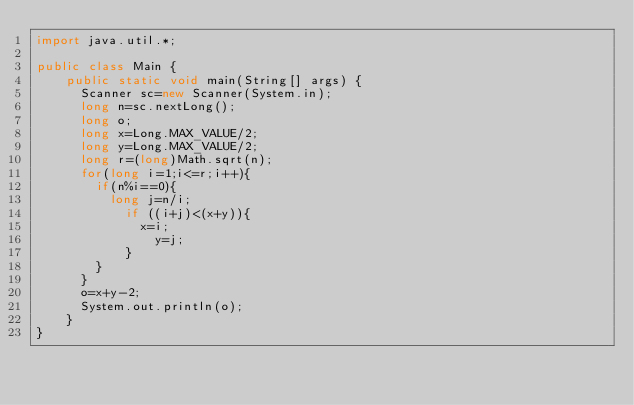<code> <loc_0><loc_0><loc_500><loc_500><_Java_>import java.util.*;

public class Main { 
    public static void main(String[] args) {
      Scanner sc=new Scanner(System.in);
      long n=sc.nextLong();
      long o;
      long x=Long.MAX_VALUE/2;
      long y=Long.MAX_VALUE/2;
      long r=(long)Math.sqrt(n);
      for(long i=1;i<=r;i++){ 
      	if(n%i==0){
        	long j=n/i;
            if ((i+j)<(x+y)){
            	x=i;
                y=j;
            }
        }
      }
      o=x+y-2;
      System.out.println(o);
    }
}</code> 